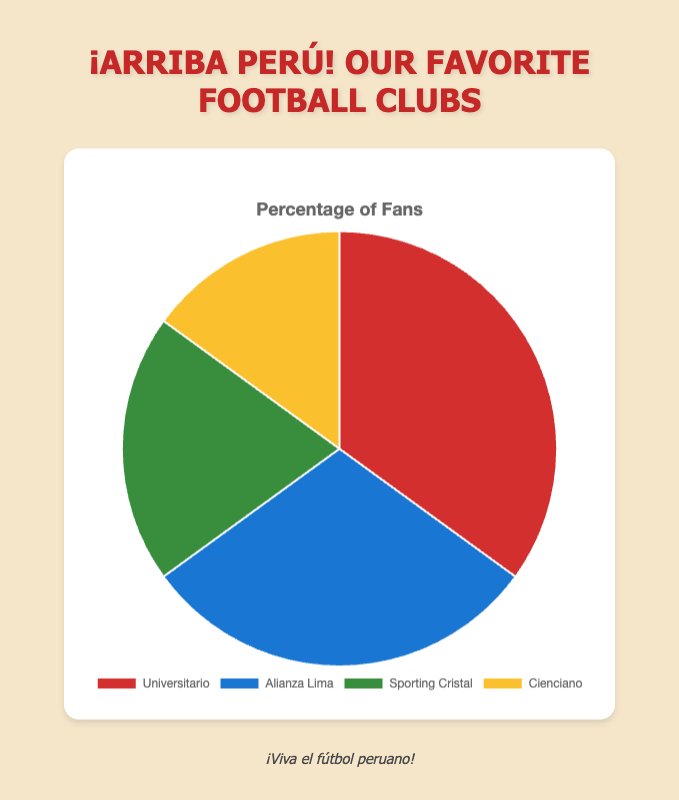Which football club has the highest percentage of fans? The pie chart shows four football clubs with their respective percentages. Universitario has the highest percentage at 35%.
Answer: Universitario How much higher is the percentage of fans for Universitario compared to Sporting Cristal? The percentage of fans for Universitario is 35%, and for Sporting Cristal, it is 20%. The difference can be calculated by subtracting 20% from 35%.
Answer: 15% What is the total percentage of fans for Alianza Lima and Cienciano combined? The percentage of fans for Alianza Lima is 30% and for Cienciano is 15%. Adding these percentages together gives 30% + 15%.
Answer: 45% Which clubs together account for less than 50% of the fans? The clubs with percentages are Universitario 35%, Alianza Lima 30%, Sporting Cristal 20%, and Cienciano 15%. Adding Sporting Cristal and Cienciano gives 20% + 15%, which is less than 50%.
Answer: Sporting Cristal and Cienciano Of the four clubs, which one has the lowest percentage of fans? The pie chart shows percentages for each club, with Cienciano having the lowest at 15%.
Answer: Cienciano What is the average fan percentage across all four football clubs? To find the average, sum the percentages of the four clubs (35% for Universitario, 30% for Alianza Lima, 20% for Sporting Cristal, and 15% for Cienciano) which totals 100%, then divide by the number of clubs, which is 4.
Answer: 25% How much less popular is Cienciano compared to Alianza Lima in terms of fan percentage? The percentage of fans for Alianza Lima is 30% and for Cienciano is 15%. The difference can be calculated by subtracting 15% from 30%.
Answer: 15% If the order of fan percentages is arranged from highest to lowest, which club would be second? Examining the percentages: Universitario is highest at 35%, followed by Alianza Lima at 30%, then Sporting Cristal at 20%, and lastly Cienciano at 15%.
Answer: Alianza Lima 